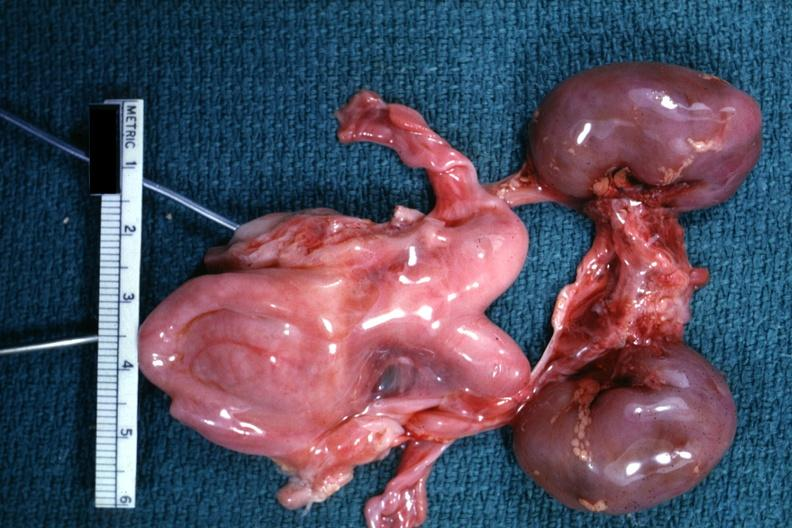what is infant organs shown?
Answer the question using a single word or phrase. Lesion 